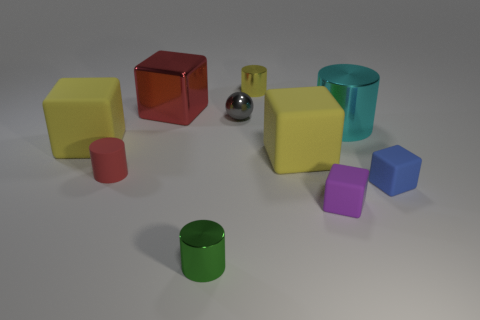What material is the big object that is the same color as the small matte cylinder?
Ensure brevity in your answer.  Metal. Are there any small rubber cylinders of the same color as the metal cube?
Provide a succinct answer. Yes. Does the small rubber cylinder have the same color as the metal block?
Your response must be concise. Yes. There is a large block behind the large shiny cylinder; is it the same color as the matte cylinder?
Offer a very short reply. Yes. Does the metal cube have the same color as the tiny rubber thing to the left of the small shiny ball?
Make the answer very short. Yes. There is a tiny purple object; is it the same shape as the red thing behind the tiny sphere?
Provide a short and direct response. Yes. The big thing that is the same color as the rubber cylinder is what shape?
Offer a terse response. Cube. There is a cube that is the same color as the matte cylinder; what size is it?
Make the answer very short. Large. What material is the small cylinder to the right of the tiny cylinder in front of the tiny red cylinder?
Your answer should be compact. Metal. There is a big red cube; are there any small shiny balls behind it?
Offer a very short reply. No. 